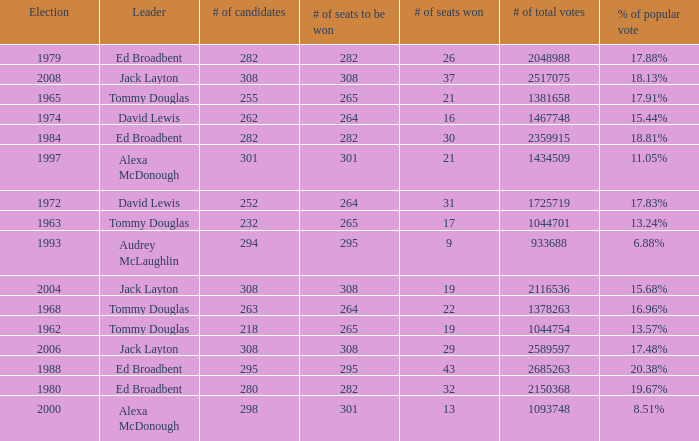Name the number of total votes for # of seats won being 30 2359915.0. 